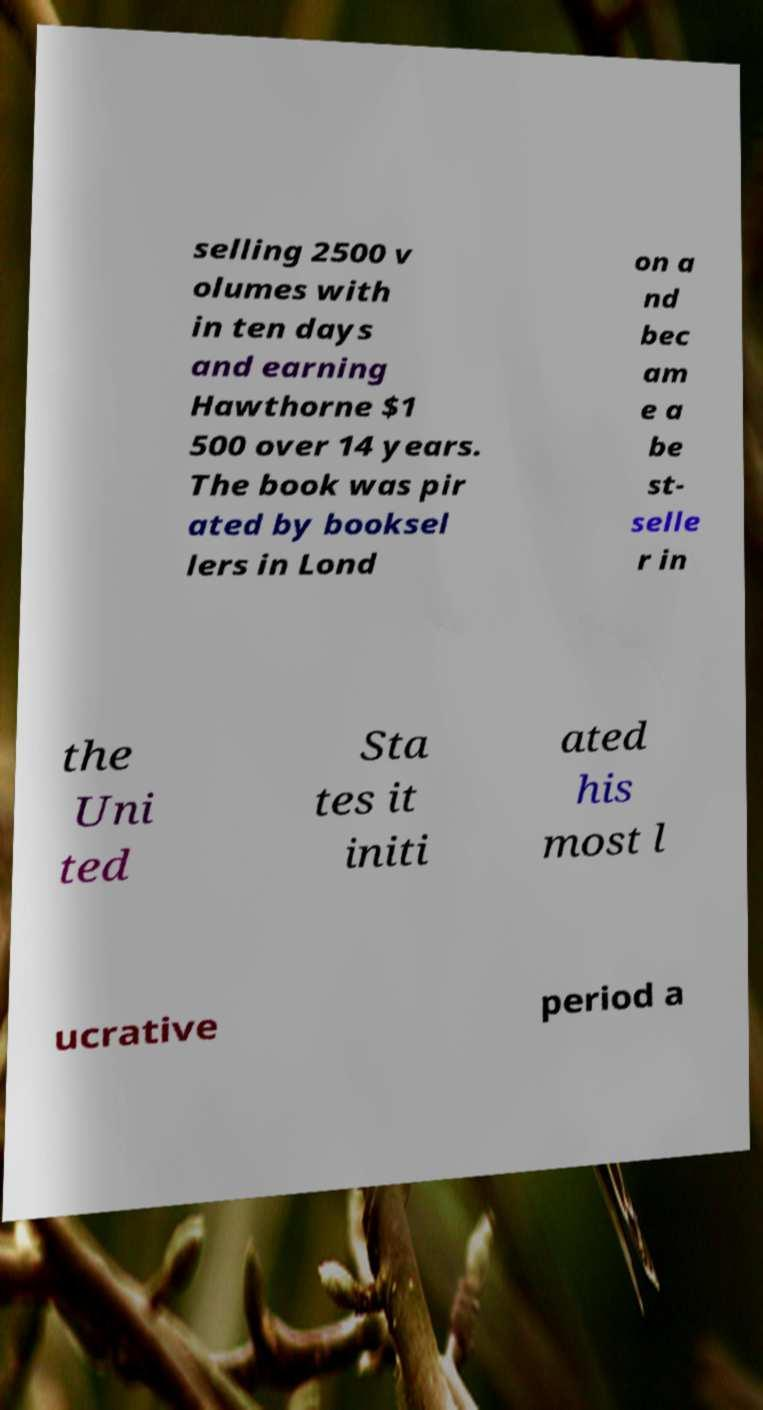I need the written content from this picture converted into text. Can you do that? selling 2500 v olumes with in ten days and earning Hawthorne $1 500 over 14 years. The book was pir ated by booksel lers in Lond on a nd bec am e a be st- selle r in the Uni ted Sta tes it initi ated his most l ucrative period a 